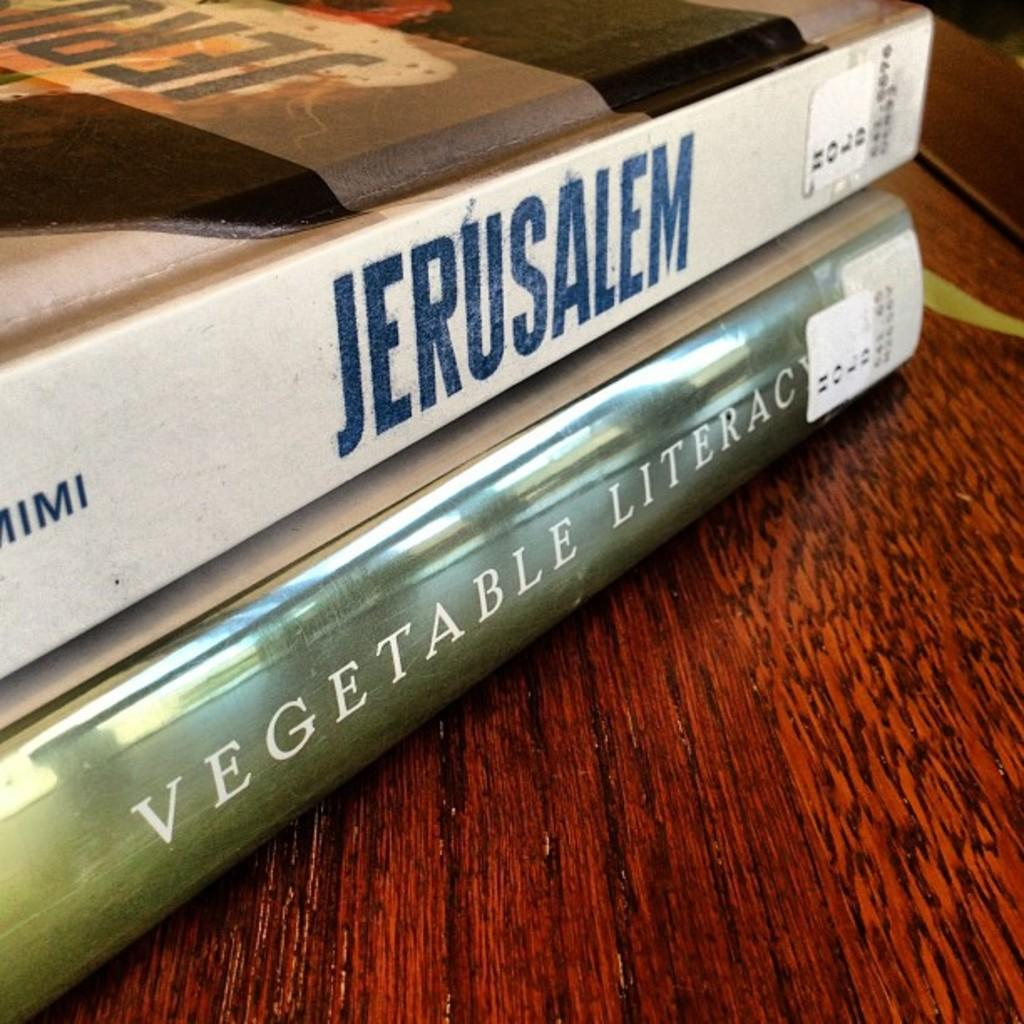<image>
Present a compact description of the photo's key features. A book titled Jerusalem is on top of another book. 